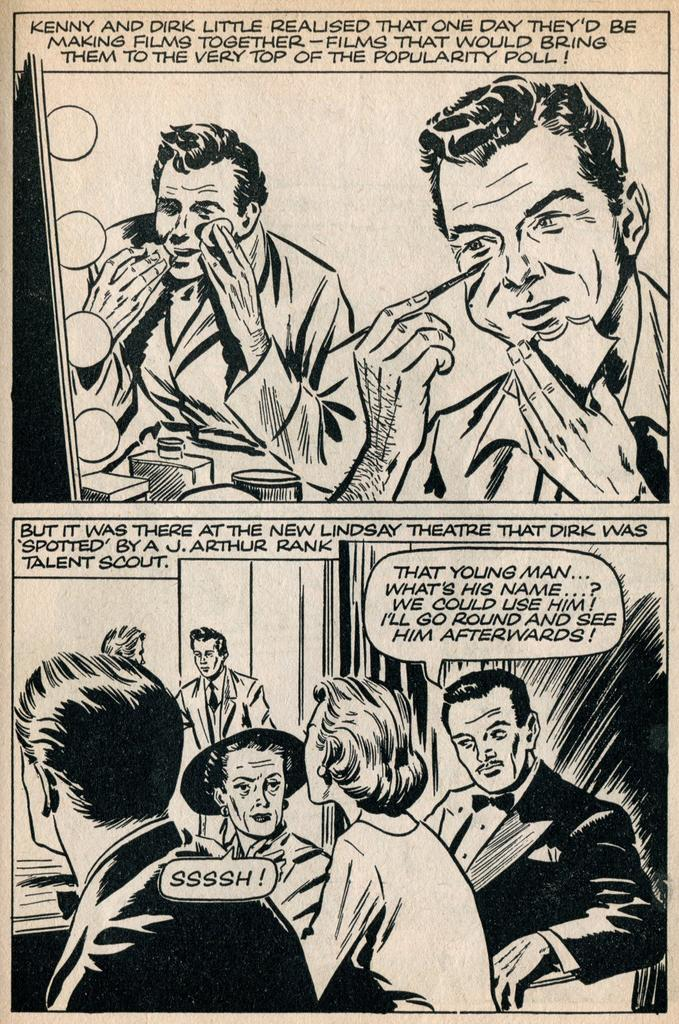<image>
Give a short and clear explanation of the subsequent image. A comic book illustration featuring men putting on making and a woman saying SSSH. 